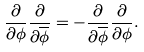<formula> <loc_0><loc_0><loc_500><loc_500>\frac { \partial } { \partial \phi } \frac { \partial } { \partial \overline { \phi } } = - \frac { \partial } { \partial \overline { \phi } } \frac { \partial } { \partial \phi } .</formula> 